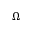<formula> <loc_0><loc_0><loc_500><loc_500>\Omega</formula> 